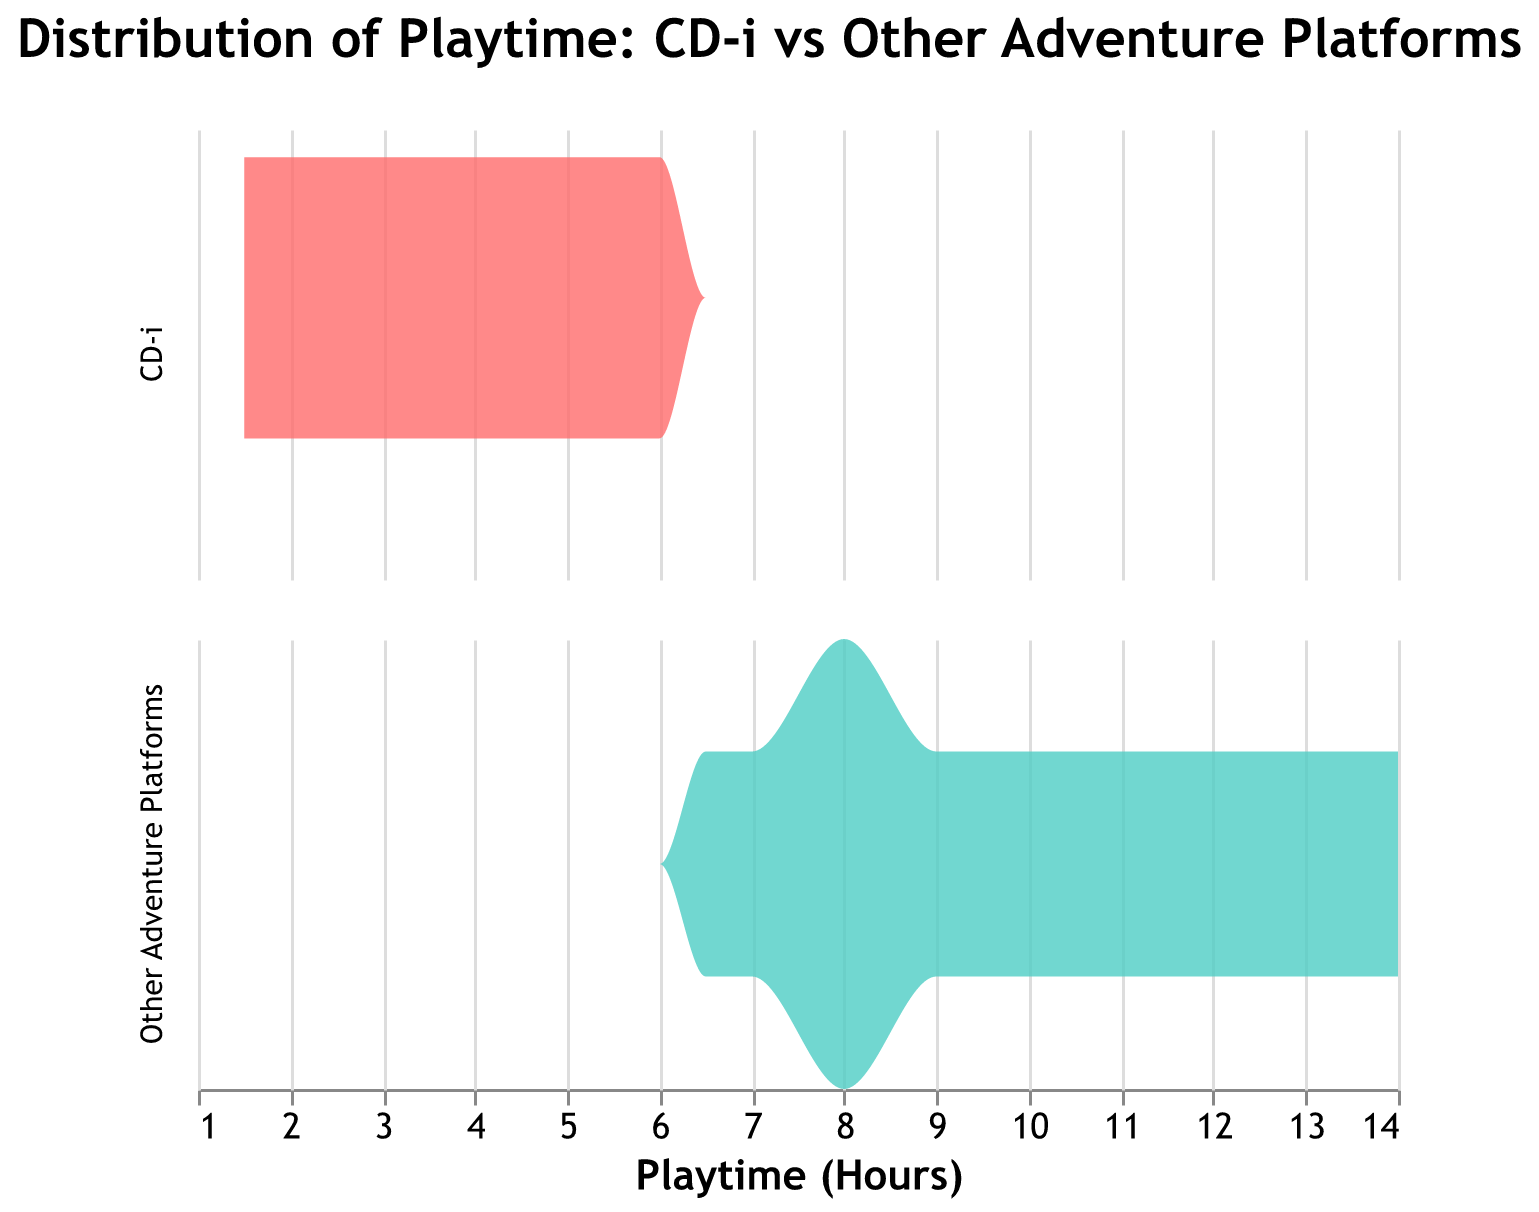What is the title of the figure? The title of the figure is usually shown at the top. The title is "Distribution of Playtime: CD-i vs Other Adventure Platforms".
Answer: Distribution of Playtime: CD-i vs Other Adventure Platforms What are the two platforms compared in the density plot? The platforms are indicated by labels on the legend or within the plot, using different colors to represent each. The two platforms compared are "CD-i" and "Other Adventure Platforms".
Answer: CD-i and Other Adventure Platforms Which platform has a higher peak density in the playtime distribution? The peak density can be identified by the highest point in the density curve for each platform. The "Other Adventure Platforms" have a higher peak density compared to "CD-i".
Answer: Other Adventure Platforms What is the range of playtime hours represented in the figure? The range of playtime can be observed on the x-axis of the plot, which indicates the span from the minimum to maximum playtime values. The range is from approximately 1.5 to 14 hours.
Answer: 1.5 to 14 hours How does the playtime density of CD-i games compare to other platforms at 6 hours? At 6 hours, compare the height of the density curves for both platforms at the 6-hour mark on the x-axis. The density of CD-i games is lower than that of other platforms at 6 hours.
Answer: Lower What is the density of the CD-i playtime distribution around 2 hours compared to 5 hours? By examining the height of the density curve for the CD-i platform at 2 hours and 5 hours on the x-axis, you can compare the density values. The density around 2 hours is slightly higher than around 5 hours.
Answer: Higher around 2 hours In which playtime range do "Other Adventure Platforms" games show the highest density? Look at the part of the curve for "Other Adventure Platforms" with the tallest peak to determine the playtime range with the highest density. The highest density for "Other Adventure Platforms" occurs around 8 to 10 hours.
Answer: 8 to 10 hours How many CD-i games are represented in the figure? Count the distinct games listed under "CD-i" in the dataset provided. There are 8 CD-i games represented in the figure.
Answer: 8 What can you infer about the average playtime for CD-i games compared to other platforms? By observing the distribution curves' general shape and central tendency, you can infer average playtime. CD-i games have less average playtime compared to the much spread-out higher playtime for other platforms.
Answer: CD-i games have less average playtime Which platform has a more diverse range of playtimes? Look at the spread of the density curves for each platform. A wider spread indicates more diversity in playtime. "Other Adventure Platforms" have a more diverse range of playtimes, spreading from around 6.5 to 14 hours, whereas CD-i’s range is narrower.
Answer: Other Adventure Platforms 